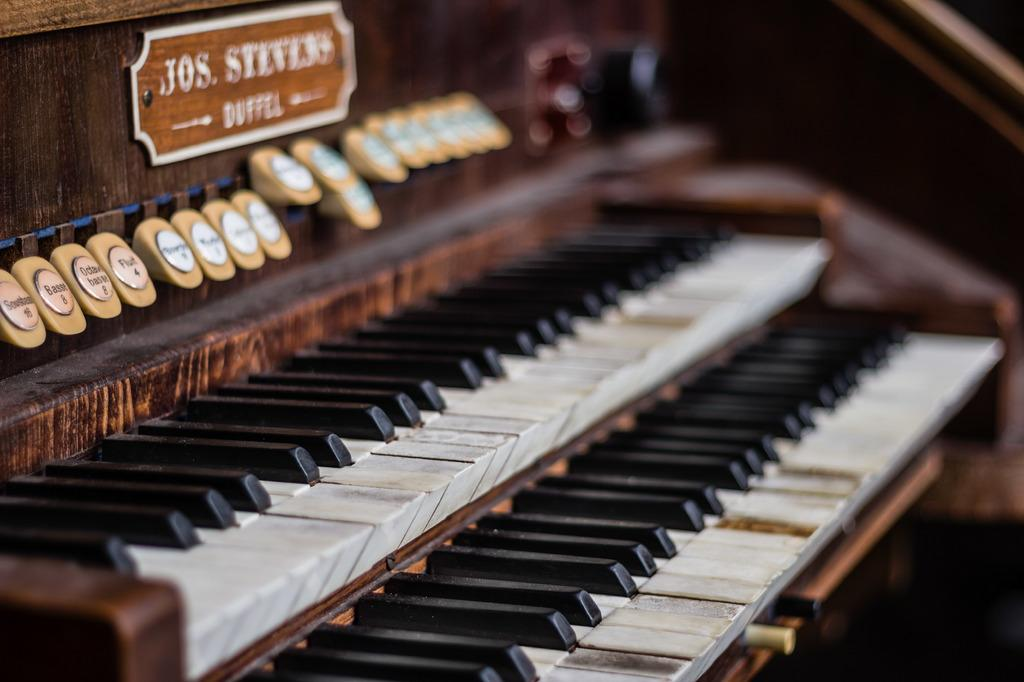What musical instrument is the main subject of the image? The main subject of the image is a piano. What type of keys does the piano have? The piano has black and white keys. What feature of the piano is mentioned in the facts? The piano has multiple buttons and a board. Can you see a kitty playing with the wing of the piano in the image? There is no kitty or wing present in the image; it features a piano with buttons and a board. 